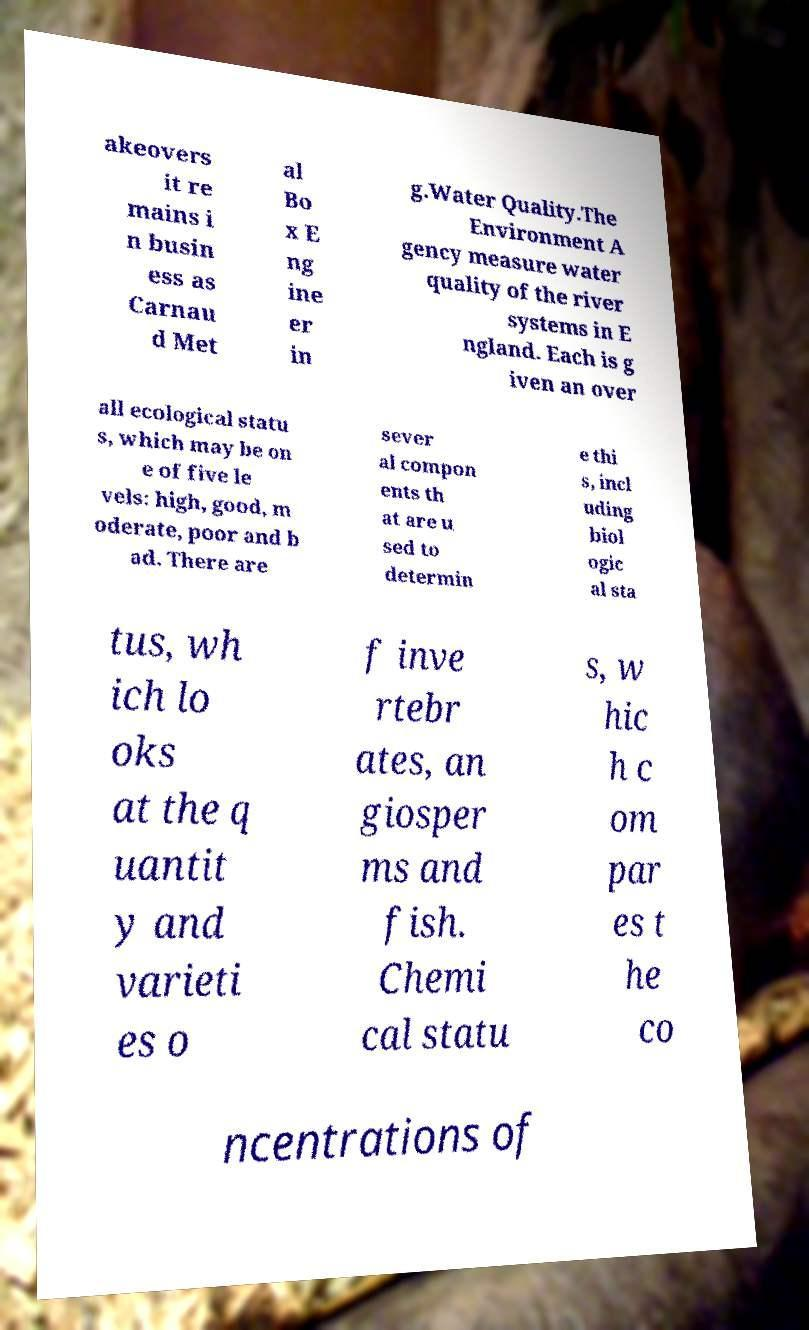There's text embedded in this image that I need extracted. Can you transcribe it verbatim? akeovers it re mains i n busin ess as Carnau d Met al Bo x E ng ine er in g.Water Quality.The Environment A gency measure water quality of the river systems in E ngland. Each is g iven an over all ecological statu s, which may be on e of five le vels: high, good, m oderate, poor and b ad. There are sever al compon ents th at are u sed to determin e thi s, incl uding biol ogic al sta tus, wh ich lo oks at the q uantit y and varieti es o f inve rtebr ates, an giosper ms and fish. Chemi cal statu s, w hic h c om par es t he co ncentrations of 